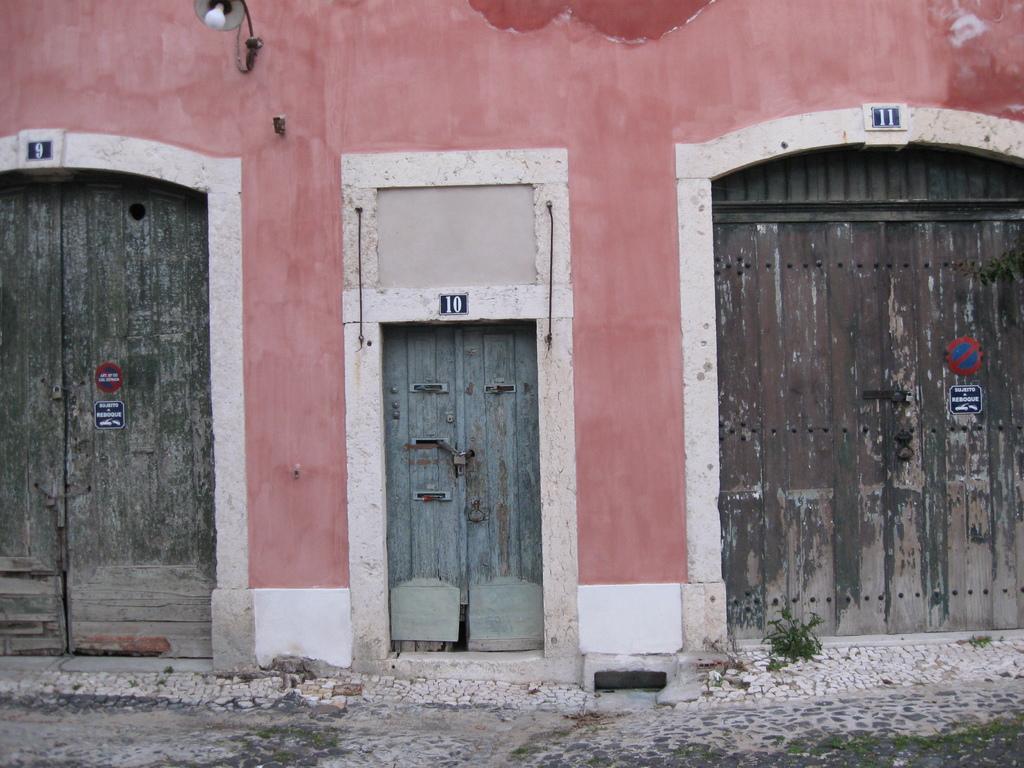In one or two sentences, can you explain what this image depicts? In the picture we can see a house wall with three doors to fit, two are big and one is small and to the wall we can see a lamp. 